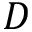Convert formula to latex. <formula><loc_0><loc_0><loc_500><loc_500>D</formula> 